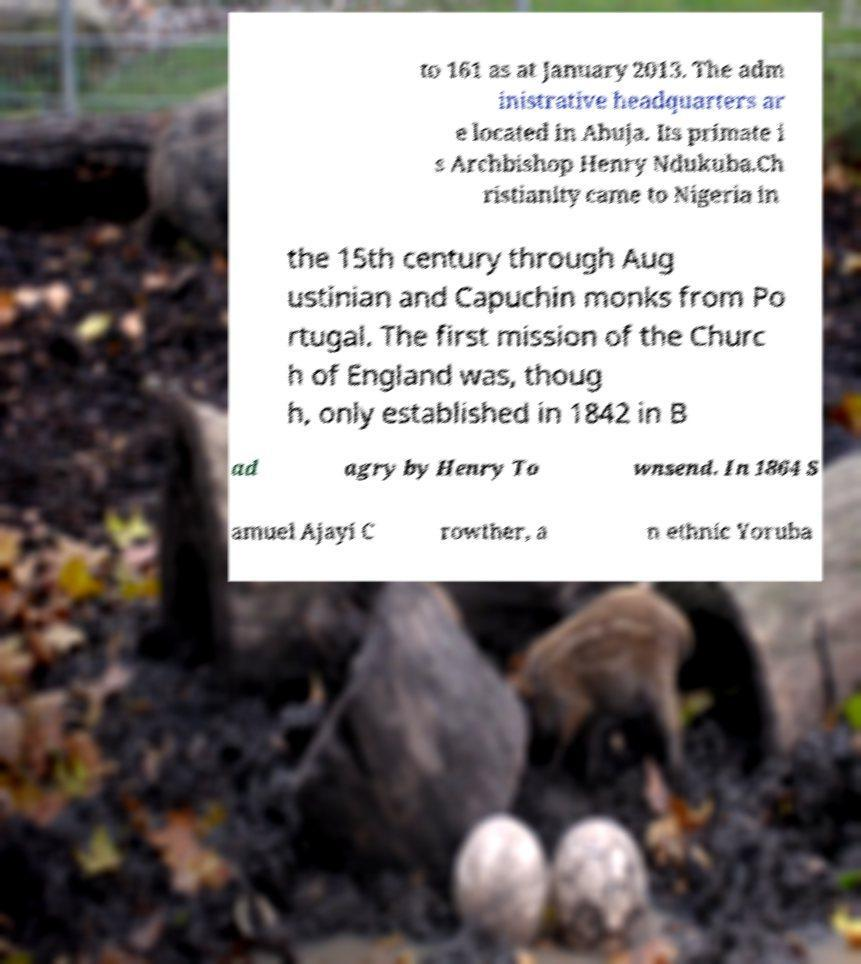For documentation purposes, I need the text within this image transcribed. Could you provide that? to 161 as at January 2013. The adm inistrative headquarters ar e located in Abuja. Its primate i s Archbishop Henry Ndukuba.Ch ristianity came to Nigeria in the 15th century through Aug ustinian and Capuchin monks from Po rtugal. The first mission of the Churc h of England was, thoug h, only established in 1842 in B ad agry by Henry To wnsend. In 1864 S amuel Ajayi C rowther, a n ethnic Yoruba 